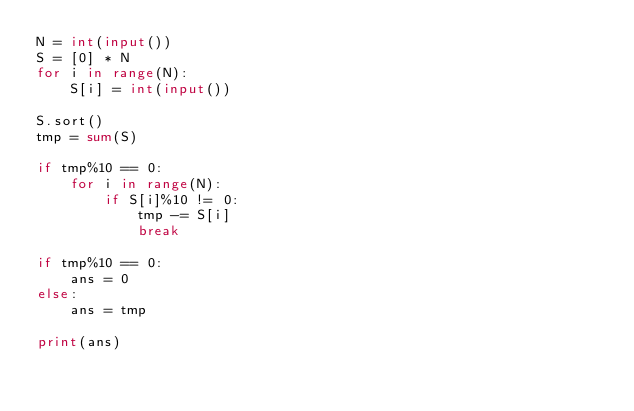<code> <loc_0><loc_0><loc_500><loc_500><_Python_>N = int(input())
S = [0] * N
for i in range(N):
    S[i] = int(input())

S.sort()
tmp = sum(S)

if tmp%10 == 0:
    for i in range(N):
        if S[i]%10 != 0:
            tmp -= S[i]
            break

if tmp%10 == 0:
    ans = 0
else:
    ans = tmp

print(ans)</code> 